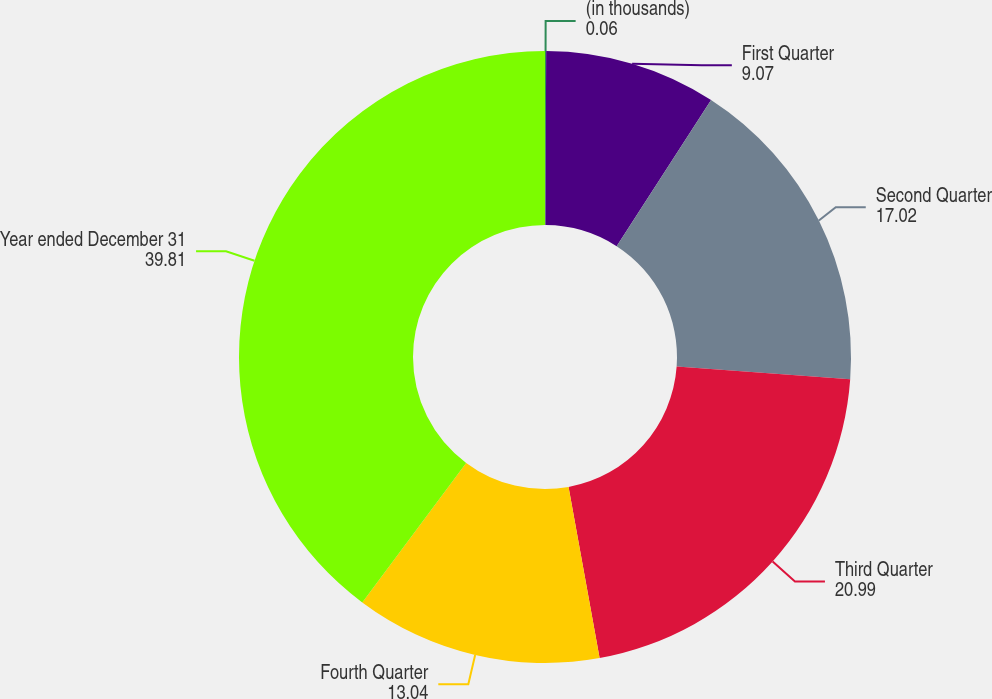Convert chart to OTSL. <chart><loc_0><loc_0><loc_500><loc_500><pie_chart><fcel>(in thousands)<fcel>First Quarter<fcel>Second Quarter<fcel>Third Quarter<fcel>Fourth Quarter<fcel>Year ended December 31<nl><fcel>0.06%<fcel>9.07%<fcel>17.02%<fcel>20.99%<fcel>13.04%<fcel>39.81%<nl></chart> 